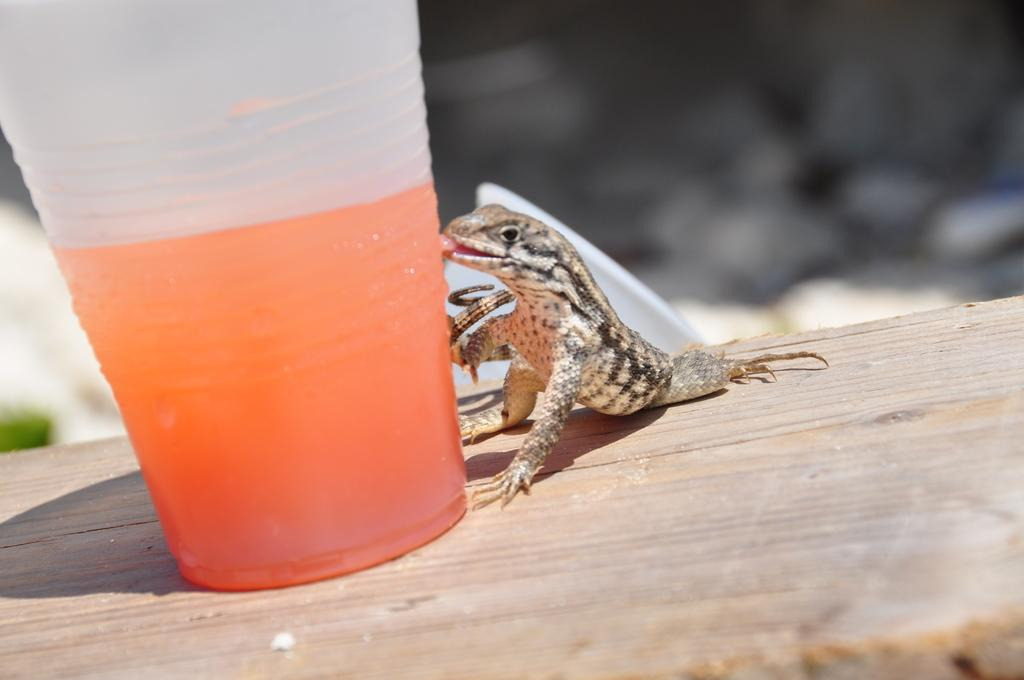What type of animal can be seen in the image? There is a lizard in the image. What object is present in the image alongside the lizard? There is a glass in the image. What is inside the glass? The glass contains an orange-colored drink. How would you describe the overall clarity of the image? The image is blurry in the background. How many birds are part of the flock in the image? There are no birds or flock present in the image; it features a lizard and a glass with an orange-colored drink. 